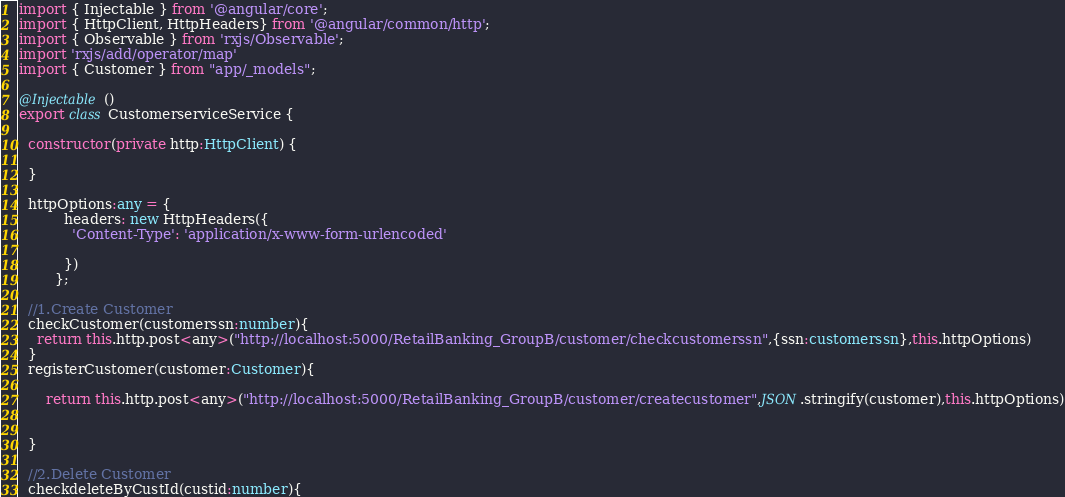Convert code to text. <code><loc_0><loc_0><loc_500><loc_500><_TypeScript_>import { Injectable } from '@angular/core';
import { HttpClient, HttpHeaders} from '@angular/common/http';
import { Observable } from 'rxjs/Observable';
import 'rxjs/add/operator/map'
import { Customer } from "app/_models";

@Injectable()
export class CustomerserviceService {

  constructor(private http:HttpClient) {

  }

  httpOptions:any = {
          headers: new HttpHeaders({
            'Content-Type': 'application/x-www-form-urlencoded'

          })
        };

  //1.Create Customer
  checkCustomer(customerssn:number){
    return this.http.post<any>("http://localhost:5000/RetailBanking_GroupB/customer/checkcustomerssn",{ssn:customerssn},this.httpOptions)
  }
  registerCustomer(customer:Customer){

      return this.http.post<any>("http://localhost:5000/RetailBanking_GroupB/customer/createcustomer",JSON.stringify(customer),this.httpOptions)


  }

  //2.Delete Customer
  checkdeleteByCustId(custid:number){</code> 